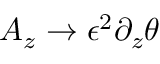Convert formula to latex. <formula><loc_0><loc_0><loc_500><loc_500>A _ { z } \rightarrow \epsilon ^ { 2 } \partial _ { z } \theta</formula> 